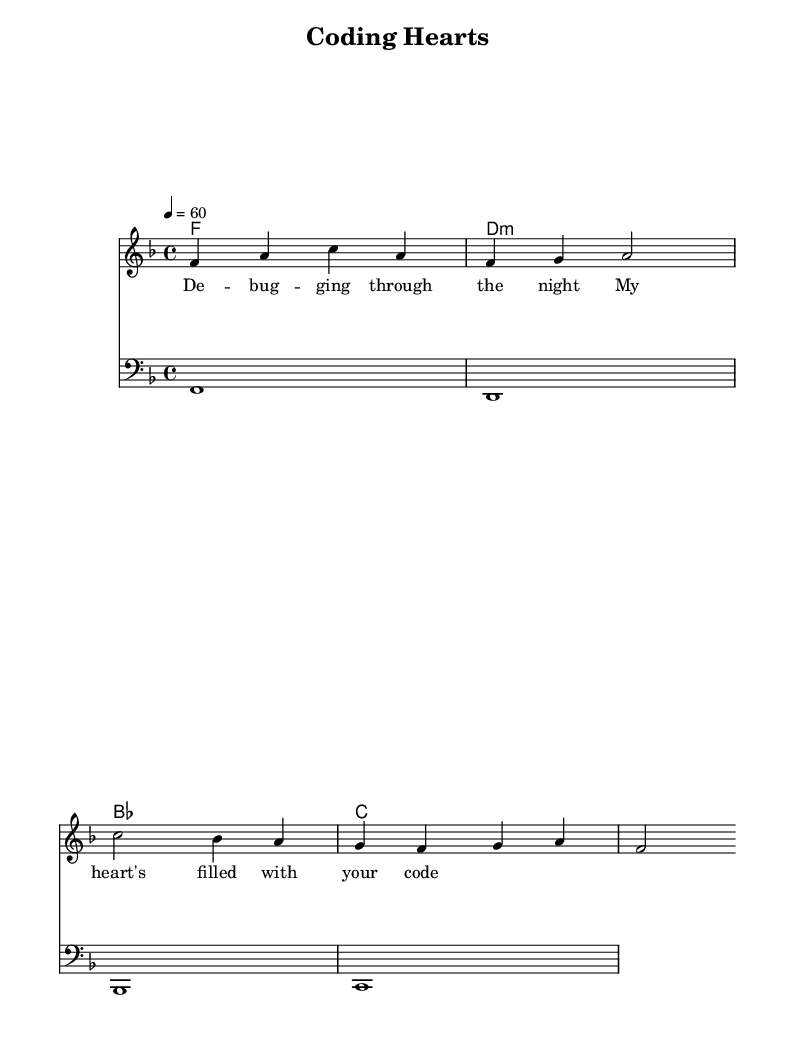What is the key signature of this music? The key signature is F major, which has one flat (B flat).
Answer: F major What is the tempo marking in this piece? The tempo marking is indicated as 60 beats per minute.
Answer: 60 What is the time signature of the piece? The time signature is 4/4, indicating four beats per measure.
Answer: 4/4 How many measures are in the melody? The melody consists of four measures in total.
Answer: Four What type of chord is played in the second measure of harmonies? The second measure indicates a D minor chord.
Answer: D minor What is the final note of the melody? The final note of the melody is an F.
Answer: F What lyrical theme is suggested in this piece? The lyrics suggest a theme of debugging and heartfelt emotions.
Answer: Debugging hearts 